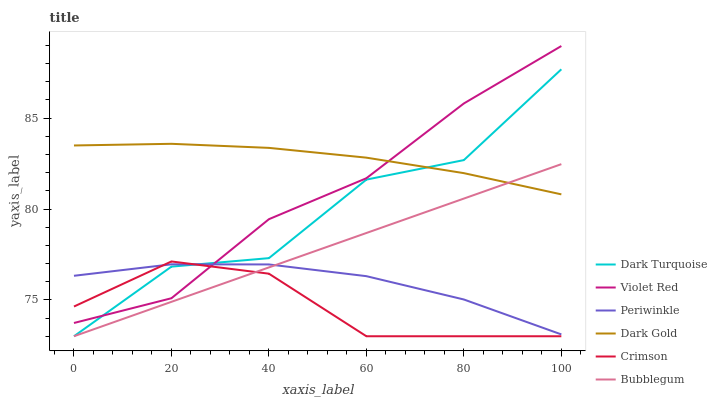Does Crimson have the minimum area under the curve?
Answer yes or no. Yes. Does Dark Gold have the maximum area under the curve?
Answer yes or no. Yes. Does Dark Turquoise have the minimum area under the curve?
Answer yes or no. No. Does Dark Turquoise have the maximum area under the curve?
Answer yes or no. No. Is Bubblegum the smoothest?
Answer yes or no. Yes. Is Dark Turquoise the roughest?
Answer yes or no. Yes. Is Dark Gold the smoothest?
Answer yes or no. No. Is Dark Gold the roughest?
Answer yes or no. No. Does Dark Turquoise have the lowest value?
Answer yes or no. Yes. Does Dark Gold have the lowest value?
Answer yes or no. No. Does Violet Red have the highest value?
Answer yes or no. Yes. Does Dark Gold have the highest value?
Answer yes or no. No. Is Bubblegum less than Violet Red?
Answer yes or no. Yes. Is Dark Gold greater than Periwinkle?
Answer yes or no. Yes. Does Dark Gold intersect Violet Red?
Answer yes or no. Yes. Is Dark Gold less than Violet Red?
Answer yes or no. No. Is Dark Gold greater than Violet Red?
Answer yes or no. No. Does Bubblegum intersect Violet Red?
Answer yes or no. No. 